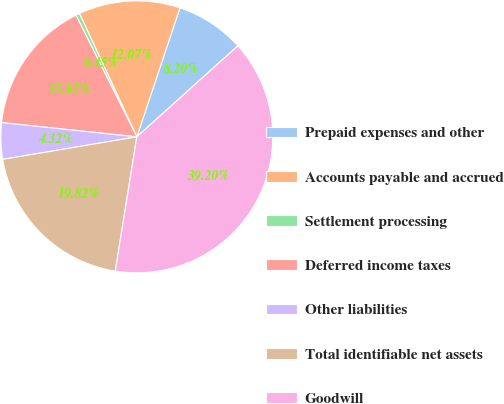<chart> <loc_0><loc_0><loc_500><loc_500><pie_chart><fcel>Prepaid expenses and other<fcel>Accounts payable and accrued<fcel>Settlement processing<fcel>Deferred income taxes<fcel>Other liabilities<fcel>Total identifiable net assets<fcel>Goodwill<nl><fcel>8.2%<fcel>12.07%<fcel>0.45%<fcel>15.95%<fcel>4.32%<fcel>19.82%<fcel>39.2%<nl></chart> 